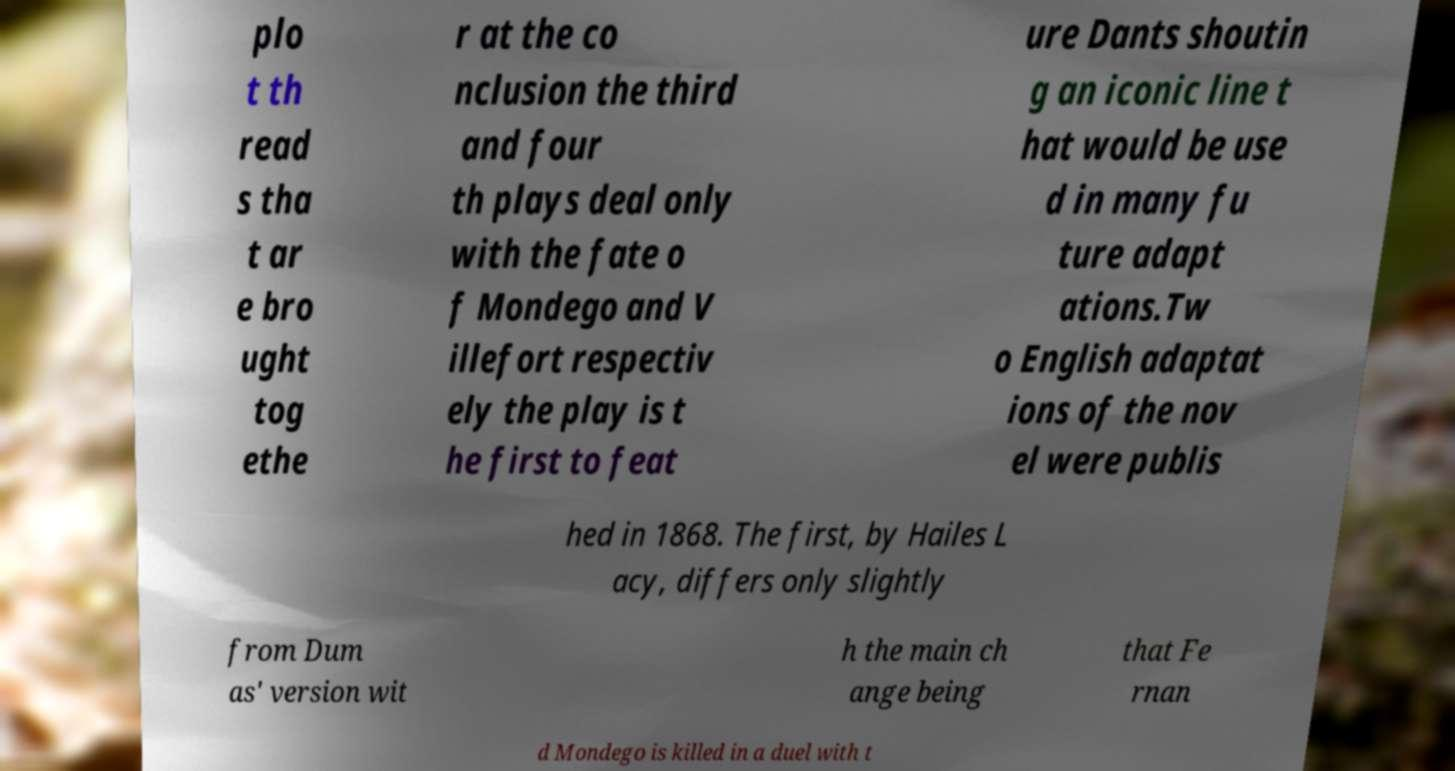Can you accurately transcribe the text from the provided image for me? plo t th read s tha t ar e bro ught tog ethe r at the co nclusion the third and four th plays deal only with the fate o f Mondego and V illefort respectiv ely the play is t he first to feat ure Dants shoutin g an iconic line t hat would be use d in many fu ture adapt ations.Tw o English adaptat ions of the nov el were publis hed in 1868. The first, by Hailes L acy, differs only slightly from Dum as' version wit h the main ch ange being that Fe rnan d Mondego is killed in a duel with t 